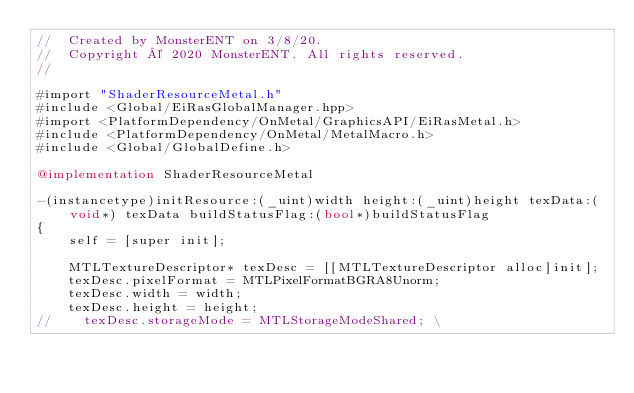Convert code to text. <code><loc_0><loc_0><loc_500><loc_500><_ObjectiveC_>//  Created by MonsterENT on 3/8/20.
//  Copyright © 2020 MonsterENT. All rights reserved.
//

#import "ShaderResourceMetal.h"
#include <Global/EiRasGlobalManager.hpp>
#import <PlatformDependency/OnMetal/GraphicsAPI/EiRasMetal.h>
#include <PlatformDependency/OnMetal/MetalMacro.h>
#include <Global/GlobalDefine.h>

@implementation ShaderResourceMetal

-(instancetype)initResource:(_uint)width height:(_uint)height texData:(void*) texData buildStatusFlag:(bool*)buildStatusFlag
{
    self = [super init];
    
    MTLTextureDescriptor* texDesc = [[MTLTextureDescriptor alloc]init];
    texDesc.pixelFormat = MTLPixelFormatBGRA8Unorm;
    texDesc.width = width;
    texDesc.height = height;
//    texDesc.storageMode = MTLStorageModeShared; \</code> 